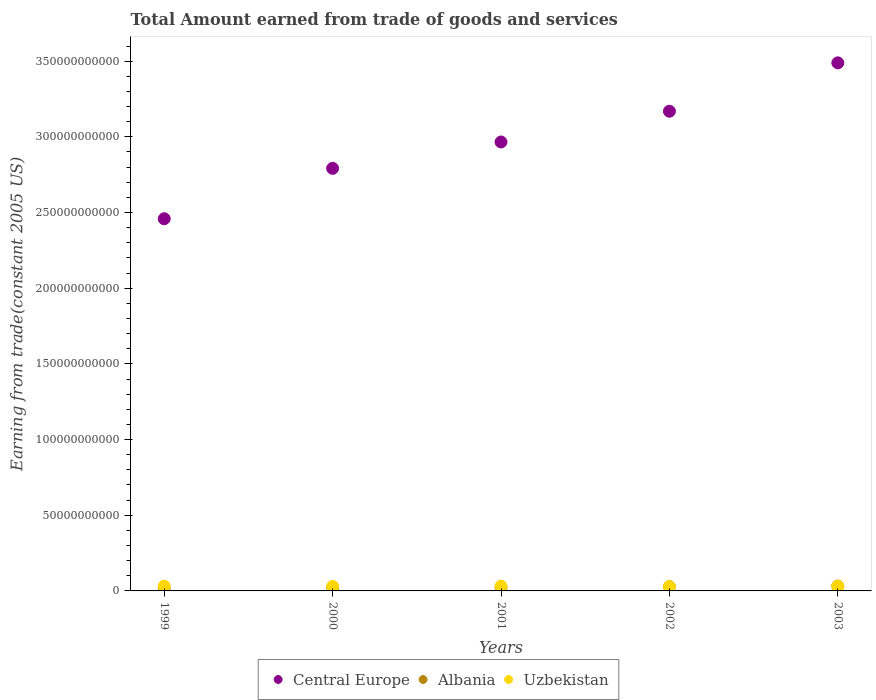How many different coloured dotlines are there?
Keep it short and to the point. 3. Is the number of dotlines equal to the number of legend labels?
Your answer should be very brief. Yes. What is the total amount earned by trading goods and services in Uzbekistan in 2000?
Your answer should be compact. 2.96e+09. Across all years, what is the maximum total amount earned by trading goods and services in Uzbekistan?
Your response must be concise. 3.15e+09. Across all years, what is the minimum total amount earned by trading goods and services in Albania?
Your answer should be very brief. 1.61e+09. What is the total total amount earned by trading goods and services in Uzbekistan in the graph?
Make the answer very short. 1.52e+1. What is the difference between the total amount earned by trading goods and services in Central Europe in 1999 and that in 2002?
Your response must be concise. -7.10e+1. What is the difference between the total amount earned by trading goods and services in Uzbekistan in 2002 and the total amount earned by trading goods and services in Albania in 2001?
Your answer should be compact. 5.67e+08. What is the average total amount earned by trading goods and services in Central Europe per year?
Offer a terse response. 2.97e+11. In the year 2003, what is the difference between the total amount earned by trading goods and services in Central Europe and total amount earned by trading goods and services in Uzbekistan?
Make the answer very short. 3.46e+11. What is the ratio of the total amount earned by trading goods and services in Central Europe in 2002 to that in 2003?
Keep it short and to the point. 0.91. Is the total amount earned by trading goods and services in Uzbekistan in 1999 less than that in 2000?
Offer a terse response. No. Is the difference between the total amount earned by trading goods and services in Central Europe in 2001 and 2003 greater than the difference between the total amount earned by trading goods and services in Uzbekistan in 2001 and 2003?
Your response must be concise. No. What is the difference between the highest and the second highest total amount earned by trading goods and services in Uzbekistan?
Make the answer very short. 8.00e+06. What is the difference between the highest and the lowest total amount earned by trading goods and services in Central Europe?
Provide a succinct answer. 1.03e+11. Does the total amount earned by trading goods and services in Uzbekistan monotonically increase over the years?
Ensure brevity in your answer.  No. How are the legend labels stacked?
Your answer should be compact. Horizontal. What is the title of the graph?
Your response must be concise. Total Amount earned from trade of goods and services. What is the label or title of the Y-axis?
Ensure brevity in your answer.  Earning from trade(constant 2005 US). What is the Earning from trade(constant 2005 US) of Central Europe in 1999?
Offer a terse response. 2.46e+11. What is the Earning from trade(constant 2005 US) of Albania in 1999?
Ensure brevity in your answer.  1.61e+09. What is the Earning from trade(constant 2005 US) in Uzbekistan in 1999?
Your answer should be compact. 3.14e+09. What is the Earning from trade(constant 2005 US) in Central Europe in 2000?
Make the answer very short. 2.79e+11. What is the Earning from trade(constant 2005 US) of Albania in 2000?
Your answer should be very brief. 2.09e+09. What is the Earning from trade(constant 2005 US) in Uzbekistan in 2000?
Your answer should be compact. 2.96e+09. What is the Earning from trade(constant 2005 US) of Central Europe in 2001?
Give a very brief answer. 2.97e+11. What is the Earning from trade(constant 2005 US) of Albania in 2001?
Offer a very short reply. 2.28e+09. What is the Earning from trade(constant 2005 US) of Uzbekistan in 2001?
Offer a terse response. 3.15e+09. What is the Earning from trade(constant 2005 US) in Central Europe in 2002?
Give a very brief answer. 3.17e+11. What is the Earning from trade(constant 2005 US) in Albania in 2002?
Give a very brief answer. 2.83e+09. What is the Earning from trade(constant 2005 US) of Uzbekistan in 2002?
Make the answer very short. 2.84e+09. What is the Earning from trade(constant 2005 US) of Central Europe in 2003?
Provide a short and direct response. 3.49e+11. What is the Earning from trade(constant 2005 US) of Albania in 2003?
Your answer should be very brief. 3.19e+09. What is the Earning from trade(constant 2005 US) in Uzbekistan in 2003?
Your answer should be compact. 3.10e+09. Across all years, what is the maximum Earning from trade(constant 2005 US) of Central Europe?
Provide a short and direct response. 3.49e+11. Across all years, what is the maximum Earning from trade(constant 2005 US) of Albania?
Provide a succinct answer. 3.19e+09. Across all years, what is the maximum Earning from trade(constant 2005 US) in Uzbekistan?
Provide a short and direct response. 3.15e+09. Across all years, what is the minimum Earning from trade(constant 2005 US) of Central Europe?
Your answer should be compact. 2.46e+11. Across all years, what is the minimum Earning from trade(constant 2005 US) of Albania?
Keep it short and to the point. 1.61e+09. Across all years, what is the minimum Earning from trade(constant 2005 US) of Uzbekistan?
Give a very brief answer. 2.84e+09. What is the total Earning from trade(constant 2005 US) of Central Europe in the graph?
Offer a very short reply. 1.49e+12. What is the total Earning from trade(constant 2005 US) of Albania in the graph?
Offer a very short reply. 1.20e+1. What is the total Earning from trade(constant 2005 US) of Uzbekistan in the graph?
Ensure brevity in your answer.  1.52e+1. What is the difference between the Earning from trade(constant 2005 US) of Central Europe in 1999 and that in 2000?
Your response must be concise. -3.33e+1. What is the difference between the Earning from trade(constant 2005 US) of Albania in 1999 and that in 2000?
Provide a succinct answer. -4.80e+08. What is the difference between the Earning from trade(constant 2005 US) of Uzbekistan in 1999 and that in 2000?
Offer a very short reply. 1.82e+08. What is the difference between the Earning from trade(constant 2005 US) in Central Europe in 1999 and that in 2001?
Make the answer very short. -5.07e+1. What is the difference between the Earning from trade(constant 2005 US) of Albania in 1999 and that in 2001?
Offer a terse response. -6.62e+08. What is the difference between the Earning from trade(constant 2005 US) in Uzbekistan in 1999 and that in 2001?
Provide a short and direct response. -8.00e+06. What is the difference between the Earning from trade(constant 2005 US) in Central Europe in 1999 and that in 2002?
Your answer should be compact. -7.10e+1. What is the difference between the Earning from trade(constant 2005 US) of Albania in 1999 and that in 2002?
Offer a very short reply. -1.22e+09. What is the difference between the Earning from trade(constant 2005 US) of Uzbekistan in 1999 and that in 2002?
Give a very brief answer. 3.01e+08. What is the difference between the Earning from trade(constant 2005 US) of Central Europe in 1999 and that in 2003?
Offer a terse response. -1.03e+11. What is the difference between the Earning from trade(constant 2005 US) in Albania in 1999 and that in 2003?
Your answer should be very brief. -1.58e+09. What is the difference between the Earning from trade(constant 2005 US) of Uzbekistan in 1999 and that in 2003?
Keep it short and to the point. 4.70e+07. What is the difference between the Earning from trade(constant 2005 US) in Central Europe in 2000 and that in 2001?
Your answer should be very brief. -1.74e+1. What is the difference between the Earning from trade(constant 2005 US) of Albania in 2000 and that in 2001?
Provide a short and direct response. -1.82e+08. What is the difference between the Earning from trade(constant 2005 US) in Uzbekistan in 2000 and that in 2001?
Your response must be concise. -1.90e+08. What is the difference between the Earning from trade(constant 2005 US) in Central Europe in 2000 and that in 2002?
Offer a terse response. -3.77e+1. What is the difference between the Earning from trade(constant 2005 US) in Albania in 2000 and that in 2002?
Make the answer very short. -7.39e+08. What is the difference between the Earning from trade(constant 2005 US) of Uzbekistan in 2000 and that in 2002?
Keep it short and to the point. 1.19e+08. What is the difference between the Earning from trade(constant 2005 US) of Central Europe in 2000 and that in 2003?
Ensure brevity in your answer.  -6.97e+1. What is the difference between the Earning from trade(constant 2005 US) of Albania in 2000 and that in 2003?
Give a very brief answer. -1.10e+09. What is the difference between the Earning from trade(constant 2005 US) of Uzbekistan in 2000 and that in 2003?
Offer a terse response. -1.35e+08. What is the difference between the Earning from trade(constant 2005 US) of Central Europe in 2001 and that in 2002?
Give a very brief answer. -2.03e+1. What is the difference between the Earning from trade(constant 2005 US) of Albania in 2001 and that in 2002?
Ensure brevity in your answer.  -5.57e+08. What is the difference between the Earning from trade(constant 2005 US) in Uzbekistan in 2001 and that in 2002?
Your answer should be compact. 3.09e+08. What is the difference between the Earning from trade(constant 2005 US) in Central Europe in 2001 and that in 2003?
Provide a succinct answer. -5.23e+1. What is the difference between the Earning from trade(constant 2005 US) of Albania in 2001 and that in 2003?
Your answer should be compact. -9.16e+08. What is the difference between the Earning from trade(constant 2005 US) of Uzbekistan in 2001 and that in 2003?
Provide a succinct answer. 5.50e+07. What is the difference between the Earning from trade(constant 2005 US) of Central Europe in 2002 and that in 2003?
Your answer should be very brief. -3.20e+1. What is the difference between the Earning from trade(constant 2005 US) of Albania in 2002 and that in 2003?
Offer a terse response. -3.60e+08. What is the difference between the Earning from trade(constant 2005 US) in Uzbekistan in 2002 and that in 2003?
Provide a short and direct response. -2.54e+08. What is the difference between the Earning from trade(constant 2005 US) in Central Europe in 1999 and the Earning from trade(constant 2005 US) in Albania in 2000?
Provide a succinct answer. 2.44e+11. What is the difference between the Earning from trade(constant 2005 US) of Central Europe in 1999 and the Earning from trade(constant 2005 US) of Uzbekistan in 2000?
Make the answer very short. 2.43e+11. What is the difference between the Earning from trade(constant 2005 US) in Albania in 1999 and the Earning from trade(constant 2005 US) in Uzbekistan in 2000?
Make the answer very short. -1.35e+09. What is the difference between the Earning from trade(constant 2005 US) of Central Europe in 1999 and the Earning from trade(constant 2005 US) of Albania in 2001?
Offer a terse response. 2.44e+11. What is the difference between the Earning from trade(constant 2005 US) of Central Europe in 1999 and the Earning from trade(constant 2005 US) of Uzbekistan in 2001?
Make the answer very short. 2.43e+11. What is the difference between the Earning from trade(constant 2005 US) in Albania in 1999 and the Earning from trade(constant 2005 US) in Uzbekistan in 2001?
Your answer should be compact. -1.54e+09. What is the difference between the Earning from trade(constant 2005 US) of Central Europe in 1999 and the Earning from trade(constant 2005 US) of Albania in 2002?
Offer a very short reply. 2.43e+11. What is the difference between the Earning from trade(constant 2005 US) of Central Europe in 1999 and the Earning from trade(constant 2005 US) of Uzbekistan in 2002?
Ensure brevity in your answer.  2.43e+11. What is the difference between the Earning from trade(constant 2005 US) in Albania in 1999 and the Earning from trade(constant 2005 US) in Uzbekistan in 2002?
Offer a very short reply. -1.23e+09. What is the difference between the Earning from trade(constant 2005 US) of Central Europe in 1999 and the Earning from trade(constant 2005 US) of Albania in 2003?
Offer a terse response. 2.43e+11. What is the difference between the Earning from trade(constant 2005 US) of Central Europe in 1999 and the Earning from trade(constant 2005 US) of Uzbekistan in 2003?
Make the answer very short. 2.43e+11. What is the difference between the Earning from trade(constant 2005 US) in Albania in 1999 and the Earning from trade(constant 2005 US) in Uzbekistan in 2003?
Offer a terse response. -1.48e+09. What is the difference between the Earning from trade(constant 2005 US) of Central Europe in 2000 and the Earning from trade(constant 2005 US) of Albania in 2001?
Provide a succinct answer. 2.77e+11. What is the difference between the Earning from trade(constant 2005 US) of Central Europe in 2000 and the Earning from trade(constant 2005 US) of Uzbekistan in 2001?
Your response must be concise. 2.76e+11. What is the difference between the Earning from trade(constant 2005 US) of Albania in 2000 and the Earning from trade(constant 2005 US) of Uzbekistan in 2001?
Provide a succinct answer. -1.06e+09. What is the difference between the Earning from trade(constant 2005 US) in Central Europe in 2000 and the Earning from trade(constant 2005 US) in Albania in 2002?
Give a very brief answer. 2.76e+11. What is the difference between the Earning from trade(constant 2005 US) of Central Europe in 2000 and the Earning from trade(constant 2005 US) of Uzbekistan in 2002?
Your answer should be compact. 2.76e+11. What is the difference between the Earning from trade(constant 2005 US) of Albania in 2000 and the Earning from trade(constant 2005 US) of Uzbekistan in 2002?
Give a very brief answer. -7.49e+08. What is the difference between the Earning from trade(constant 2005 US) in Central Europe in 2000 and the Earning from trade(constant 2005 US) in Albania in 2003?
Offer a terse response. 2.76e+11. What is the difference between the Earning from trade(constant 2005 US) of Central Europe in 2000 and the Earning from trade(constant 2005 US) of Uzbekistan in 2003?
Your answer should be very brief. 2.76e+11. What is the difference between the Earning from trade(constant 2005 US) of Albania in 2000 and the Earning from trade(constant 2005 US) of Uzbekistan in 2003?
Offer a terse response. -1.00e+09. What is the difference between the Earning from trade(constant 2005 US) of Central Europe in 2001 and the Earning from trade(constant 2005 US) of Albania in 2002?
Your answer should be very brief. 2.94e+11. What is the difference between the Earning from trade(constant 2005 US) of Central Europe in 2001 and the Earning from trade(constant 2005 US) of Uzbekistan in 2002?
Provide a short and direct response. 2.94e+11. What is the difference between the Earning from trade(constant 2005 US) in Albania in 2001 and the Earning from trade(constant 2005 US) in Uzbekistan in 2002?
Offer a very short reply. -5.67e+08. What is the difference between the Earning from trade(constant 2005 US) of Central Europe in 2001 and the Earning from trade(constant 2005 US) of Albania in 2003?
Your answer should be compact. 2.93e+11. What is the difference between the Earning from trade(constant 2005 US) of Central Europe in 2001 and the Earning from trade(constant 2005 US) of Uzbekistan in 2003?
Keep it short and to the point. 2.93e+11. What is the difference between the Earning from trade(constant 2005 US) in Albania in 2001 and the Earning from trade(constant 2005 US) in Uzbekistan in 2003?
Offer a very short reply. -8.21e+08. What is the difference between the Earning from trade(constant 2005 US) of Central Europe in 2002 and the Earning from trade(constant 2005 US) of Albania in 2003?
Give a very brief answer. 3.14e+11. What is the difference between the Earning from trade(constant 2005 US) in Central Europe in 2002 and the Earning from trade(constant 2005 US) in Uzbekistan in 2003?
Ensure brevity in your answer.  3.14e+11. What is the difference between the Earning from trade(constant 2005 US) of Albania in 2002 and the Earning from trade(constant 2005 US) of Uzbekistan in 2003?
Provide a short and direct response. -2.64e+08. What is the average Earning from trade(constant 2005 US) of Central Europe per year?
Offer a very short reply. 2.97e+11. What is the average Earning from trade(constant 2005 US) in Albania per year?
Provide a succinct answer. 2.40e+09. What is the average Earning from trade(constant 2005 US) in Uzbekistan per year?
Give a very brief answer. 3.04e+09. In the year 1999, what is the difference between the Earning from trade(constant 2005 US) of Central Europe and Earning from trade(constant 2005 US) of Albania?
Make the answer very short. 2.44e+11. In the year 1999, what is the difference between the Earning from trade(constant 2005 US) of Central Europe and Earning from trade(constant 2005 US) of Uzbekistan?
Offer a very short reply. 2.43e+11. In the year 1999, what is the difference between the Earning from trade(constant 2005 US) in Albania and Earning from trade(constant 2005 US) in Uzbekistan?
Your response must be concise. -1.53e+09. In the year 2000, what is the difference between the Earning from trade(constant 2005 US) of Central Europe and Earning from trade(constant 2005 US) of Albania?
Ensure brevity in your answer.  2.77e+11. In the year 2000, what is the difference between the Earning from trade(constant 2005 US) of Central Europe and Earning from trade(constant 2005 US) of Uzbekistan?
Your response must be concise. 2.76e+11. In the year 2000, what is the difference between the Earning from trade(constant 2005 US) in Albania and Earning from trade(constant 2005 US) in Uzbekistan?
Provide a succinct answer. -8.68e+08. In the year 2001, what is the difference between the Earning from trade(constant 2005 US) of Central Europe and Earning from trade(constant 2005 US) of Albania?
Your answer should be compact. 2.94e+11. In the year 2001, what is the difference between the Earning from trade(constant 2005 US) of Central Europe and Earning from trade(constant 2005 US) of Uzbekistan?
Offer a terse response. 2.93e+11. In the year 2001, what is the difference between the Earning from trade(constant 2005 US) in Albania and Earning from trade(constant 2005 US) in Uzbekistan?
Offer a very short reply. -8.76e+08. In the year 2002, what is the difference between the Earning from trade(constant 2005 US) in Central Europe and Earning from trade(constant 2005 US) in Albania?
Your answer should be compact. 3.14e+11. In the year 2002, what is the difference between the Earning from trade(constant 2005 US) of Central Europe and Earning from trade(constant 2005 US) of Uzbekistan?
Provide a short and direct response. 3.14e+11. In the year 2002, what is the difference between the Earning from trade(constant 2005 US) in Albania and Earning from trade(constant 2005 US) in Uzbekistan?
Provide a succinct answer. -1.02e+07. In the year 2003, what is the difference between the Earning from trade(constant 2005 US) in Central Europe and Earning from trade(constant 2005 US) in Albania?
Your answer should be very brief. 3.46e+11. In the year 2003, what is the difference between the Earning from trade(constant 2005 US) in Central Europe and Earning from trade(constant 2005 US) in Uzbekistan?
Keep it short and to the point. 3.46e+11. In the year 2003, what is the difference between the Earning from trade(constant 2005 US) of Albania and Earning from trade(constant 2005 US) of Uzbekistan?
Make the answer very short. 9.55e+07. What is the ratio of the Earning from trade(constant 2005 US) in Central Europe in 1999 to that in 2000?
Provide a succinct answer. 0.88. What is the ratio of the Earning from trade(constant 2005 US) in Albania in 1999 to that in 2000?
Offer a very short reply. 0.77. What is the ratio of the Earning from trade(constant 2005 US) of Uzbekistan in 1999 to that in 2000?
Offer a terse response. 1.06. What is the ratio of the Earning from trade(constant 2005 US) in Central Europe in 1999 to that in 2001?
Provide a succinct answer. 0.83. What is the ratio of the Earning from trade(constant 2005 US) in Albania in 1999 to that in 2001?
Make the answer very short. 0.71. What is the ratio of the Earning from trade(constant 2005 US) of Central Europe in 1999 to that in 2002?
Offer a terse response. 0.78. What is the ratio of the Earning from trade(constant 2005 US) of Albania in 1999 to that in 2002?
Ensure brevity in your answer.  0.57. What is the ratio of the Earning from trade(constant 2005 US) of Uzbekistan in 1999 to that in 2002?
Ensure brevity in your answer.  1.11. What is the ratio of the Earning from trade(constant 2005 US) of Central Europe in 1999 to that in 2003?
Make the answer very short. 0.7. What is the ratio of the Earning from trade(constant 2005 US) in Albania in 1999 to that in 2003?
Give a very brief answer. 0.51. What is the ratio of the Earning from trade(constant 2005 US) in Uzbekistan in 1999 to that in 2003?
Offer a very short reply. 1.02. What is the ratio of the Earning from trade(constant 2005 US) in Central Europe in 2000 to that in 2001?
Keep it short and to the point. 0.94. What is the ratio of the Earning from trade(constant 2005 US) of Albania in 2000 to that in 2001?
Provide a succinct answer. 0.92. What is the ratio of the Earning from trade(constant 2005 US) in Uzbekistan in 2000 to that in 2001?
Provide a short and direct response. 0.94. What is the ratio of the Earning from trade(constant 2005 US) of Central Europe in 2000 to that in 2002?
Your answer should be compact. 0.88. What is the ratio of the Earning from trade(constant 2005 US) in Albania in 2000 to that in 2002?
Your response must be concise. 0.74. What is the ratio of the Earning from trade(constant 2005 US) of Uzbekistan in 2000 to that in 2002?
Make the answer very short. 1.04. What is the ratio of the Earning from trade(constant 2005 US) in Central Europe in 2000 to that in 2003?
Give a very brief answer. 0.8. What is the ratio of the Earning from trade(constant 2005 US) of Albania in 2000 to that in 2003?
Provide a short and direct response. 0.66. What is the ratio of the Earning from trade(constant 2005 US) of Uzbekistan in 2000 to that in 2003?
Offer a terse response. 0.96. What is the ratio of the Earning from trade(constant 2005 US) of Central Europe in 2001 to that in 2002?
Your response must be concise. 0.94. What is the ratio of the Earning from trade(constant 2005 US) of Albania in 2001 to that in 2002?
Ensure brevity in your answer.  0.8. What is the ratio of the Earning from trade(constant 2005 US) of Uzbekistan in 2001 to that in 2002?
Offer a very short reply. 1.11. What is the ratio of the Earning from trade(constant 2005 US) of Central Europe in 2001 to that in 2003?
Provide a short and direct response. 0.85. What is the ratio of the Earning from trade(constant 2005 US) in Albania in 2001 to that in 2003?
Provide a short and direct response. 0.71. What is the ratio of the Earning from trade(constant 2005 US) in Uzbekistan in 2001 to that in 2003?
Your response must be concise. 1.02. What is the ratio of the Earning from trade(constant 2005 US) in Central Europe in 2002 to that in 2003?
Provide a short and direct response. 0.91. What is the ratio of the Earning from trade(constant 2005 US) of Albania in 2002 to that in 2003?
Provide a succinct answer. 0.89. What is the ratio of the Earning from trade(constant 2005 US) of Uzbekistan in 2002 to that in 2003?
Ensure brevity in your answer.  0.92. What is the difference between the highest and the second highest Earning from trade(constant 2005 US) in Central Europe?
Your answer should be compact. 3.20e+1. What is the difference between the highest and the second highest Earning from trade(constant 2005 US) of Albania?
Provide a short and direct response. 3.60e+08. What is the difference between the highest and the lowest Earning from trade(constant 2005 US) in Central Europe?
Provide a succinct answer. 1.03e+11. What is the difference between the highest and the lowest Earning from trade(constant 2005 US) of Albania?
Ensure brevity in your answer.  1.58e+09. What is the difference between the highest and the lowest Earning from trade(constant 2005 US) in Uzbekistan?
Give a very brief answer. 3.09e+08. 